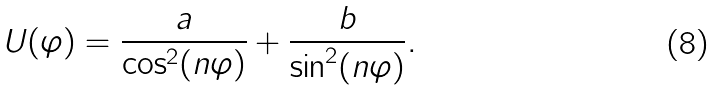<formula> <loc_0><loc_0><loc_500><loc_500>U ( \varphi ) = \frac { a } { \cos ^ { 2 } ( n \varphi ) } + \frac { b } { \sin ^ { 2 } ( n \varphi ) } .</formula> 